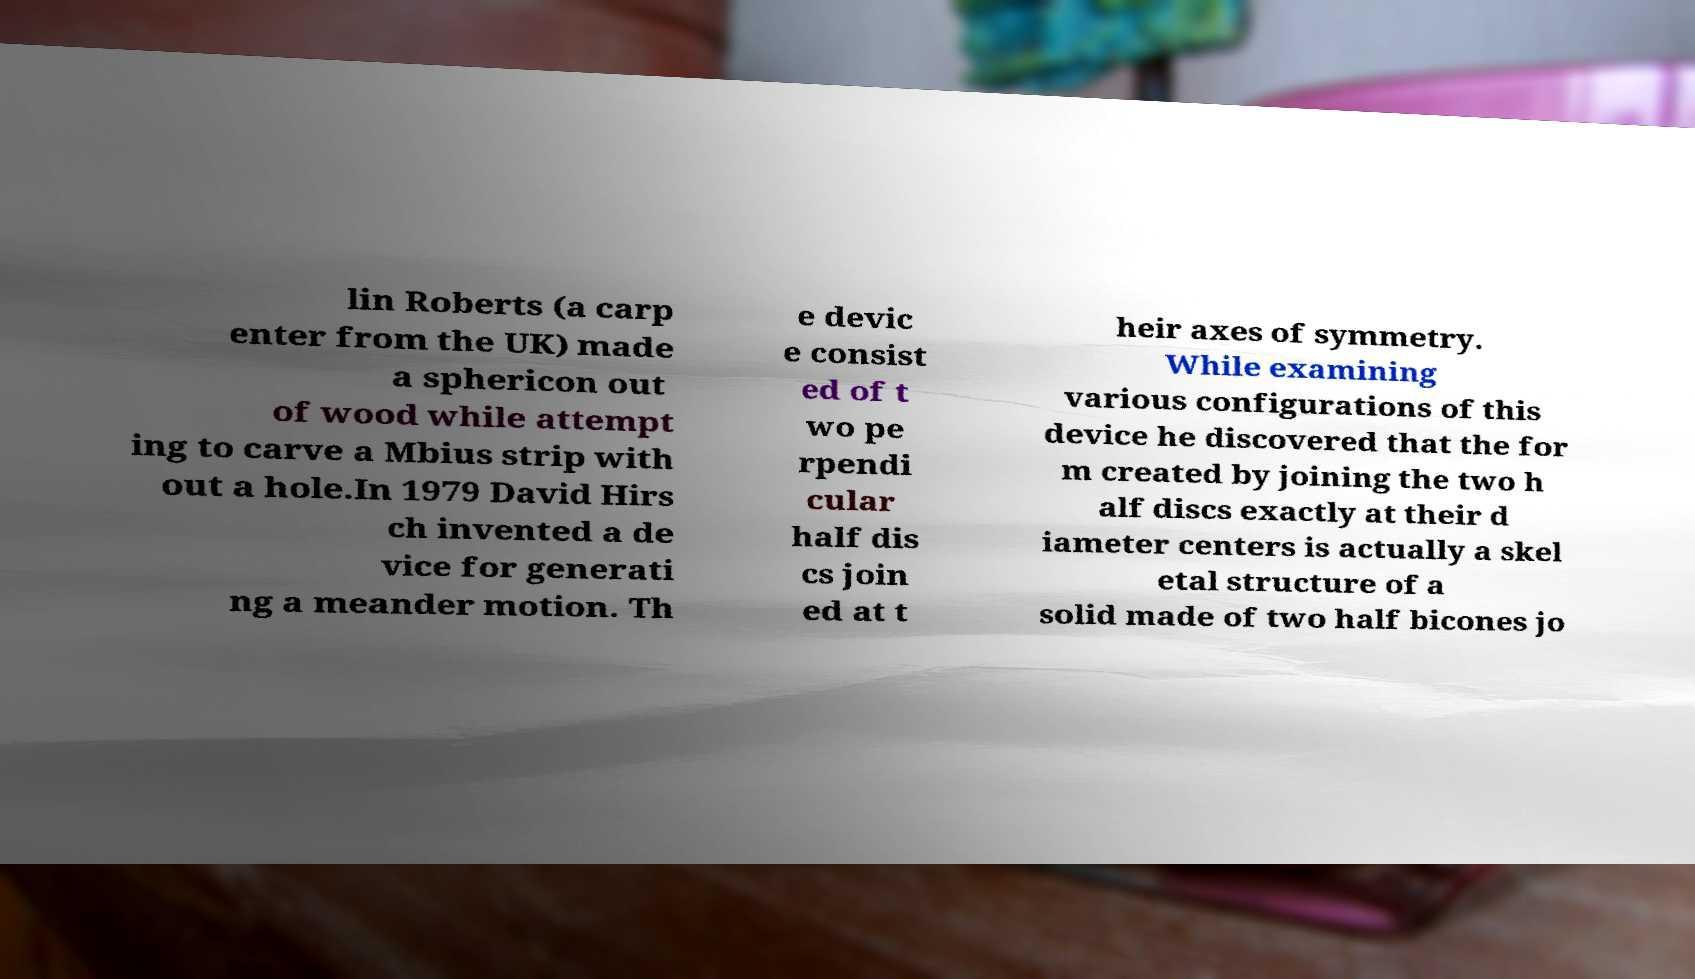Could you extract and type out the text from this image? lin Roberts (a carp enter from the UK) made a sphericon out of wood while attempt ing to carve a Mbius strip with out a hole.In 1979 David Hirs ch invented a de vice for generati ng a meander motion. Th e devic e consist ed of t wo pe rpendi cular half dis cs join ed at t heir axes of symmetry. While examining various configurations of this device he discovered that the for m created by joining the two h alf discs exactly at their d iameter centers is actually a skel etal structure of a solid made of two half bicones jo 